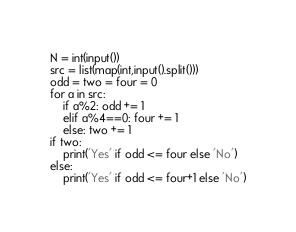<code> <loc_0><loc_0><loc_500><loc_500><_Python_>N = int(input())
src = list(map(int,input().split()))
odd = two = four = 0
for a in src:
    if a%2: odd += 1
    elif a%4==0: four += 1
    else: two += 1
if two:
    print('Yes' if odd <= four else 'No')
else:
    print('Yes' if odd <= four+1 else 'No')</code> 